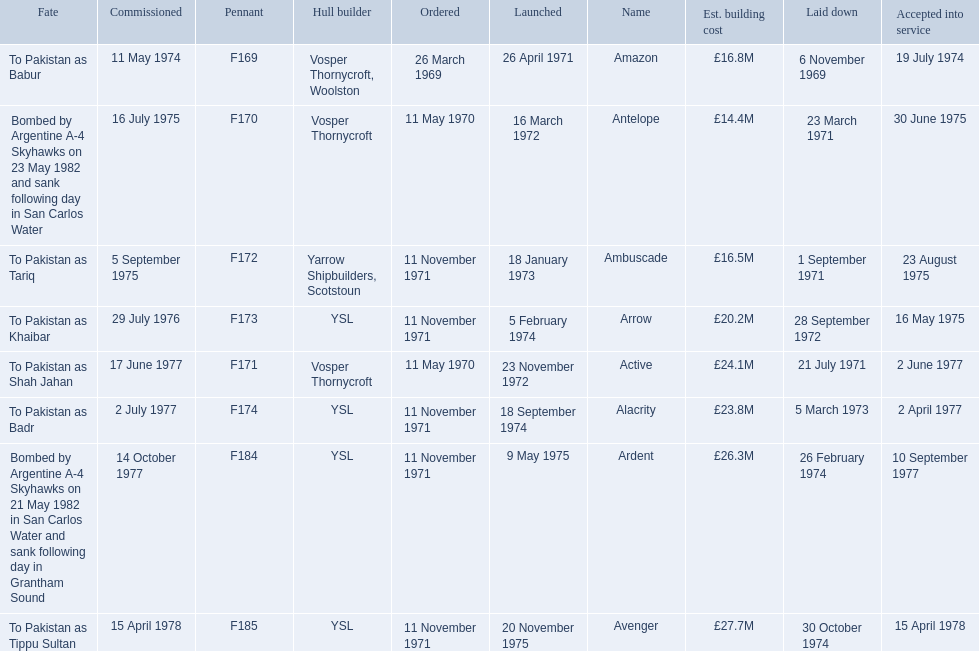Which ships cost more than ps25.0m to build? Ardent, Avenger. Of the ships listed in the answer above, which one cost the most to build? Avenger. 